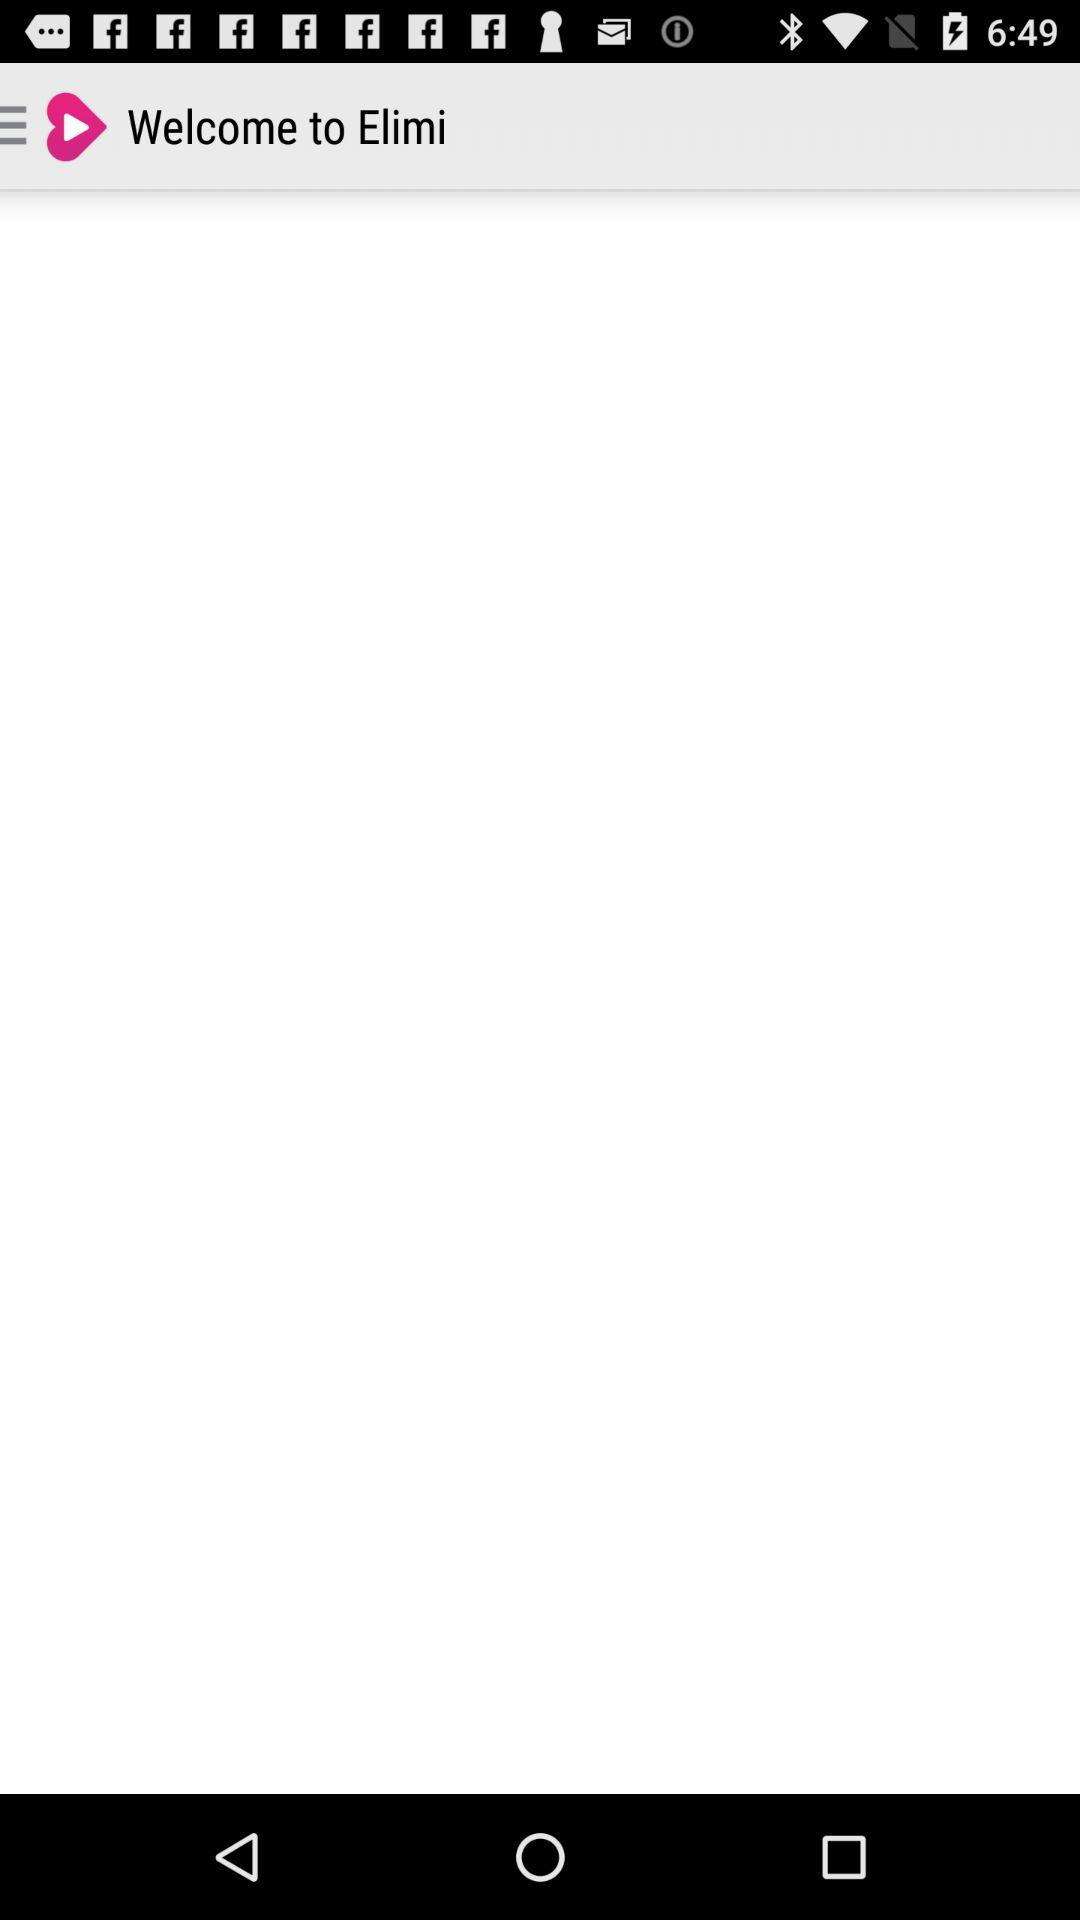What is the application name? The application name is "Elimi". 